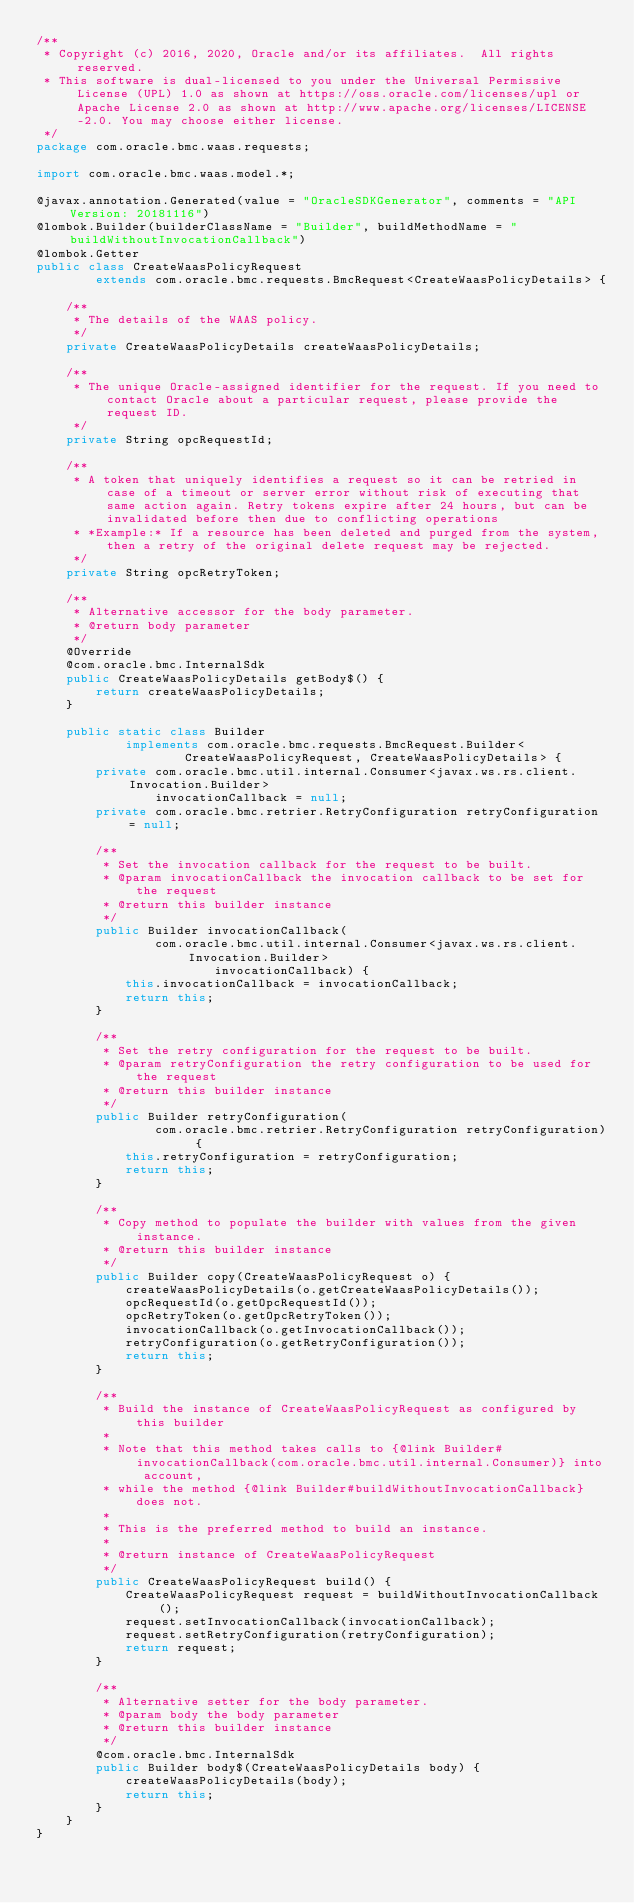Convert code to text. <code><loc_0><loc_0><loc_500><loc_500><_Java_>/**
 * Copyright (c) 2016, 2020, Oracle and/or its affiliates.  All rights reserved.
 * This software is dual-licensed to you under the Universal Permissive License (UPL) 1.0 as shown at https://oss.oracle.com/licenses/upl or Apache License 2.0 as shown at http://www.apache.org/licenses/LICENSE-2.0. You may choose either license.
 */
package com.oracle.bmc.waas.requests;

import com.oracle.bmc.waas.model.*;

@javax.annotation.Generated(value = "OracleSDKGenerator", comments = "API Version: 20181116")
@lombok.Builder(builderClassName = "Builder", buildMethodName = "buildWithoutInvocationCallback")
@lombok.Getter
public class CreateWaasPolicyRequest
        extends com.oracle.bmc.requests.BmcRequest<CreateWaasPolicyDetails> {

    /**
     * The details of the WAAS policy.
     */
    private CreateWaasPolicyDetails createWaasPolicyDetails;

    /**
     * The unique Oracle-assigned identifier for the request. If you need to contact Oracle about a particular request, please provide the request ID.
     */
    private String opcRequestId;

    /**
     * A token that uniquely identifies a request so it can be retried in case of a timeout or server error without risk of executing that same action again. Retry tokens expire after 24 hours, but can be invalidated before then due to conflicting operations
     * *Example:* If a resource has been deleted and purged from the system, then a retry of the original delete request may be rejected.
     */
    private String opcRetryToken;

    /**
     * Alternative accessor for the body parameter.
     * @return body parameter
     */
    @Override
    @com.oracle.bmc.InternalSdk
    public CreateWaasPolicyDetails getBody$() {
        return createWaasPolicyDetails;
    }

    public static class Builder
            implements com.oracle.bmc.requests.BmcRequest.Builder<
                    CreateWaasPolicyRequest, CreateWaasPolicyDetails> {
        private com.oracle.bmc.util.internal.Consumer<javax.ws.rs.client.Invocation.Builder>
                invocationCallback = null;
        private com.oracle.bmc.retrier.RetryConfiguration retryConfiguration = null;

        /**
         * Set the invocation callback for the request to be built.
         * @param invocationCallback the invocation callback to be set for the request
         * @return this builder instance
         */
        public Builder invocationCallback(
                com.oracle.bmc.util.internal.Consumer<javax.ws.rs.client.Invocation.Builder>
                        invocationCallback) {
            this.invocationCallback = invocationCallback;
            return this;
        }

        /**
         * Set the retry configuration for the request to be built.
         * @param retryConfiguration the retry configuration to be used for the request
         * @return this builder instance
         */
        public Builder retryConfiguration(
                com.oracle.bmc.retrier.RetryConfiguration retryConfiguration) {
            this.retryConfiguration = retryConfiguration;
            return this;
        }

        /**
         * Copy method to populate the builder with values from the given instance.
         * @return this builder instance
         */
        public Builder copy(CreateWaasPolicyRequest o) {
            createWaasPolicyDetails(o.getCreateWaasPolicyDetails());
            opcRequestId(o.getOpcRequestId());
            opcRetryToken(o.getOpcRetryToken());
            invocationCallback(o.getInvocationCallback());
            retryConfiguration(o.getRetryConfiguration());
            return this;
        }

        /**
         * Build the instance of CreateWaasPolicyRequest as configured by this builder
         *
         * Note that this method takes calls to {@link Builder#invocationCallback(com.oracle.bmc.util.internal.Consumer)} into account,
         * while the method {@link Builder#buildWithoutInvocationCallback} does not.
         *
         * This is the preferred method to build an instance.
         *
         * @return instance of CreateWaasPolicyRequest
         */
        public CreateWaasPolicyRequest build() {
            CreateWaasPolicyRequest request = buildWithoutInvocationCallback();
            request.setInvocationCallback(invocationCallback);
            request.setRetryConfiguration(retryConfiguration);
            return request;
        }

        /**
         * Alternative setter for the body parameter.
         * @param body the body parameter
         * @return this builder instance
         */
        @com.oracle.bmc.InternalSdk
        public Builder body$(CreateWaasPolicyDetails body) {
            createWaasPolicyDetails(body);
            return this;
        }
    }
}
</code> 